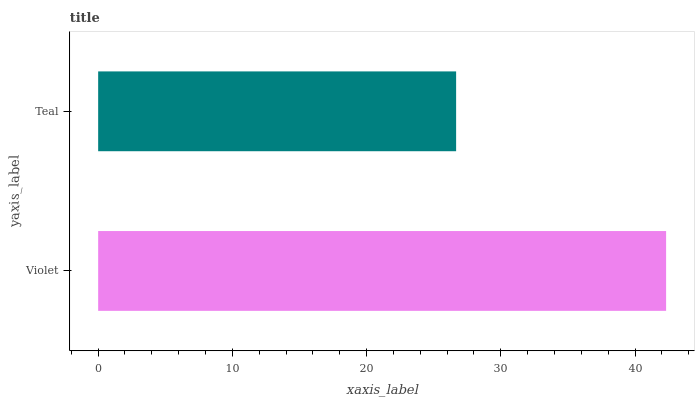Is Teal the minimum?
Answer yes or no. Yes. Is Violet the maximum?
Answer yes or no. Yes. Is Teal the maximum?
Answer yes or no. No. Is Violet greater than Teal?
Answer yes or no. Yes. Is Teal less than Violet?
Answer yes or no. Yes. Is Teal greater than Violet?
Answer yes or no. No. Is Violet less than Teal?
Answer yes or no. No. Is Violet the high median?
Answer yes or no. Yes. Is Teal the low median?
Answer yes or no. Yes. Is Teal the high median?
Answer yes or no. No. Is Violet the low median?
Answer yes or no. No. 